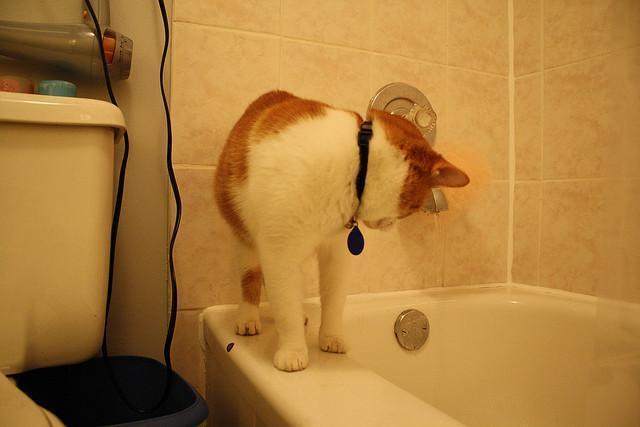How many women are wearing white dresses?
Give a very brief answer. 0. 